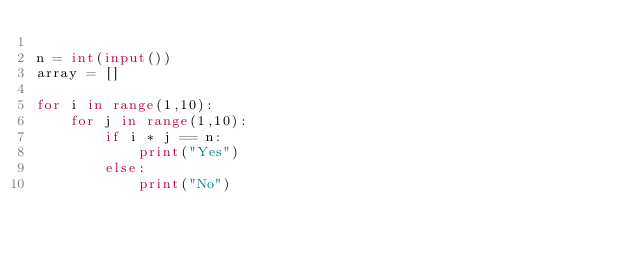<code> <loc_0><loc_0><loc_500><loc_500><_Python_>
n = int(input())
array = []

for i in range(1,10):
    for j in range(1,10):
        if i * j == n:
            print("Yes")
        else:
            print("No")</code> 